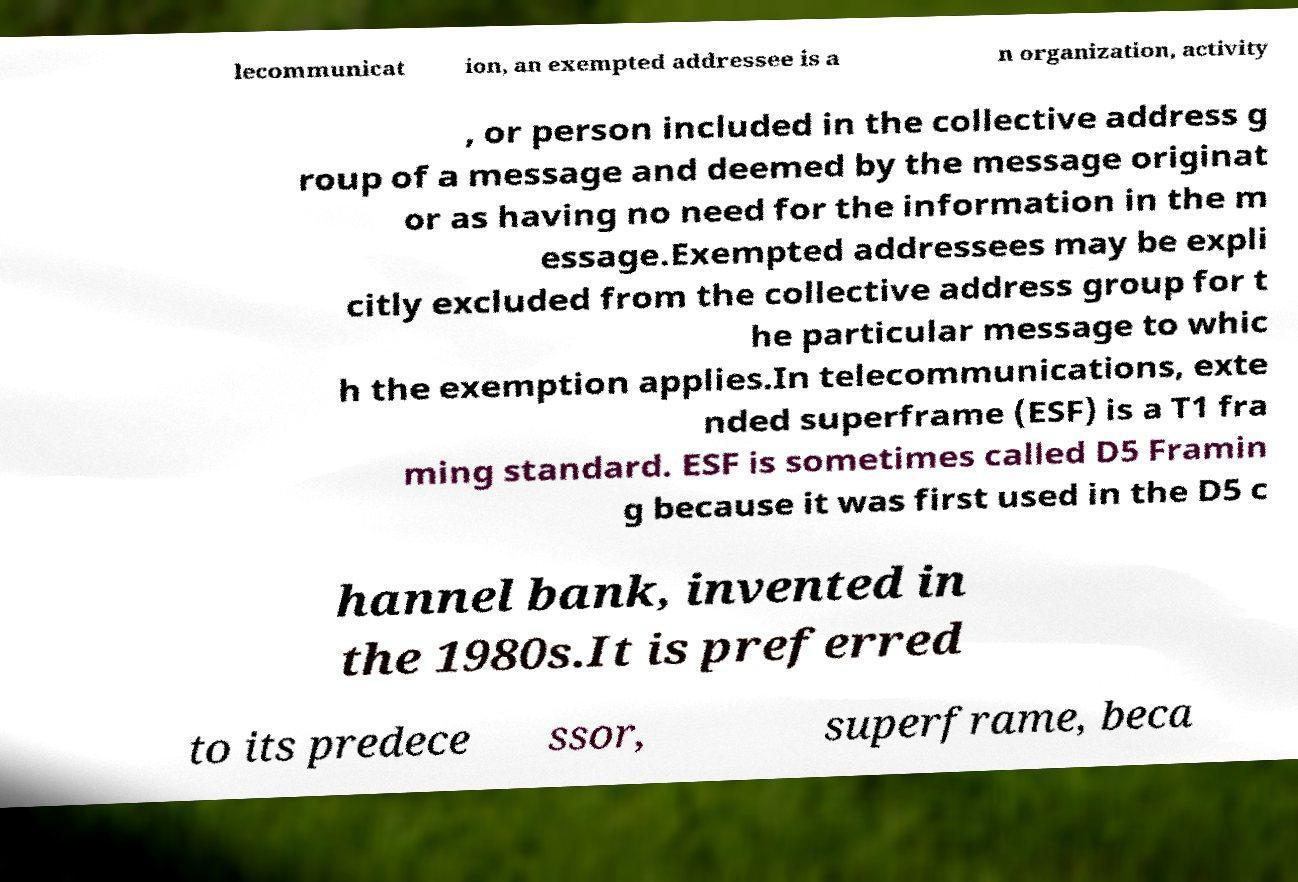Could you extract and type out the text from this image? lecommunicat ion, an exempted addressee is a n organization, activity , or person included in the collective address g roup of a message and deemed by the message originat or as having no need for the information in the m essage.Exempted addressees may be expli citly excluded from the collective address group for t he particular message to whic h the exemption applies.In telecommunications, exte nded superframe (ESF) is a T1 fra ming standard. ESF is sometimes called D5 Framin g because it was first used in the D5 c hannel bank, invented in the 1980s.It is preferred to its predece ssor, superframe, beca 